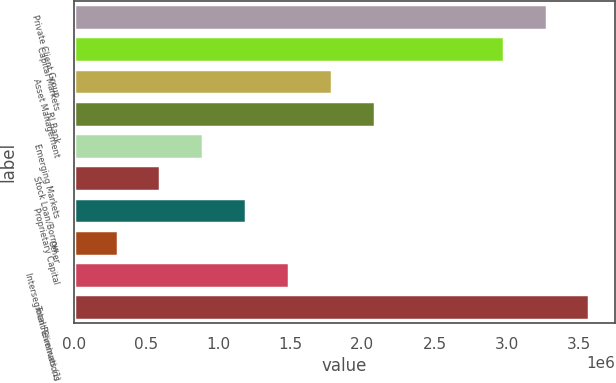Convert chart. <chart><loc_0><loc_0><loc_500><loc_500><bar_chart><fcel>Private Client Group<fcel>Capital Markets<fcel>Asset Management<fcel>RJ Bank<fcel>Emerging Markets<fcel>Stock Loan/Borrow<fcel>Proprietary Capital<fcel>Other<fcel>Intersegment Eliminations<fcel>Total Revenues (1)<nl><fcel>3.27689e+06<fcel>2.97952e+06<fcel>1.79002e+06<fcel>2.08739e+06<fcel>897890<fcel>600514<fcel>1.19526e+06<fcel>303139<fcel>1.49264e+06<fcel>3.57427e+06<nl></chart> 